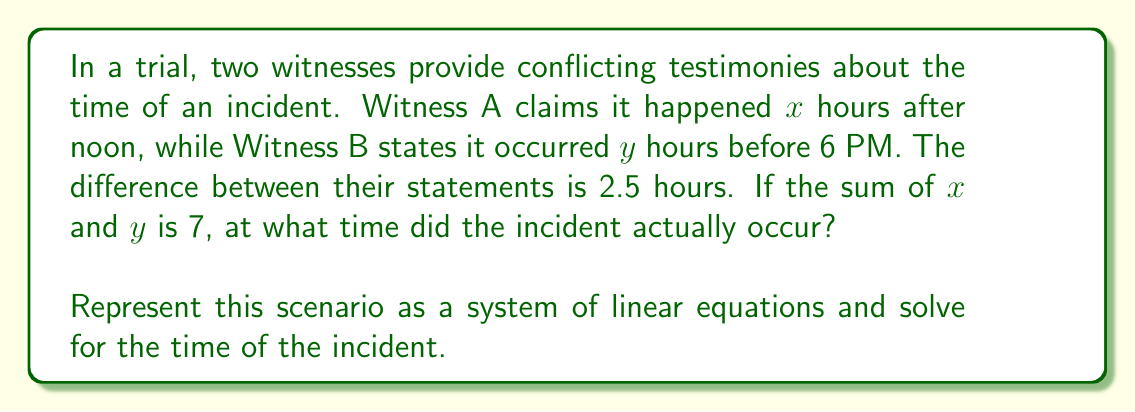Provide a solution to this math problem. Let's approach this step-by-step:

1) First, let's set up our system of equations based on the given information:

   Equation 1: $x + y = 7$ (sum of their time statements)
   Equation 2: $x - y = 2.5$ (difference between their statements)

2) We can solve this system using the elimination method:

3) Add the two equations:
   
   $$(x + y) + (x - y) = 7 + 2.5$$
   $$2x = 9.5$$

4) Solve for $x$:
   
   $$x = \frac{9.5}{2} = 4.75$$

5) Substitute this value of $x$ into Equation 1 to find $y$:

   $$4.75 + y = 7$$
   $$y = 7 - 4.75 = 2.25$$

6) Now, we know that the incident occurred 4.75 hours after noon.

7) To convert this to a standard time:
   
   12:00 PM + 4 hours = 4:00 PM
   0.75 hours = 45 minutes

   So, 4:00 PM + 45 minutes = 4:45 PM

Therefore, based on solving the system of equations derived from the witness testimonies, the incident occurred at 4:45 PM.
Answer: 4:45 PM 